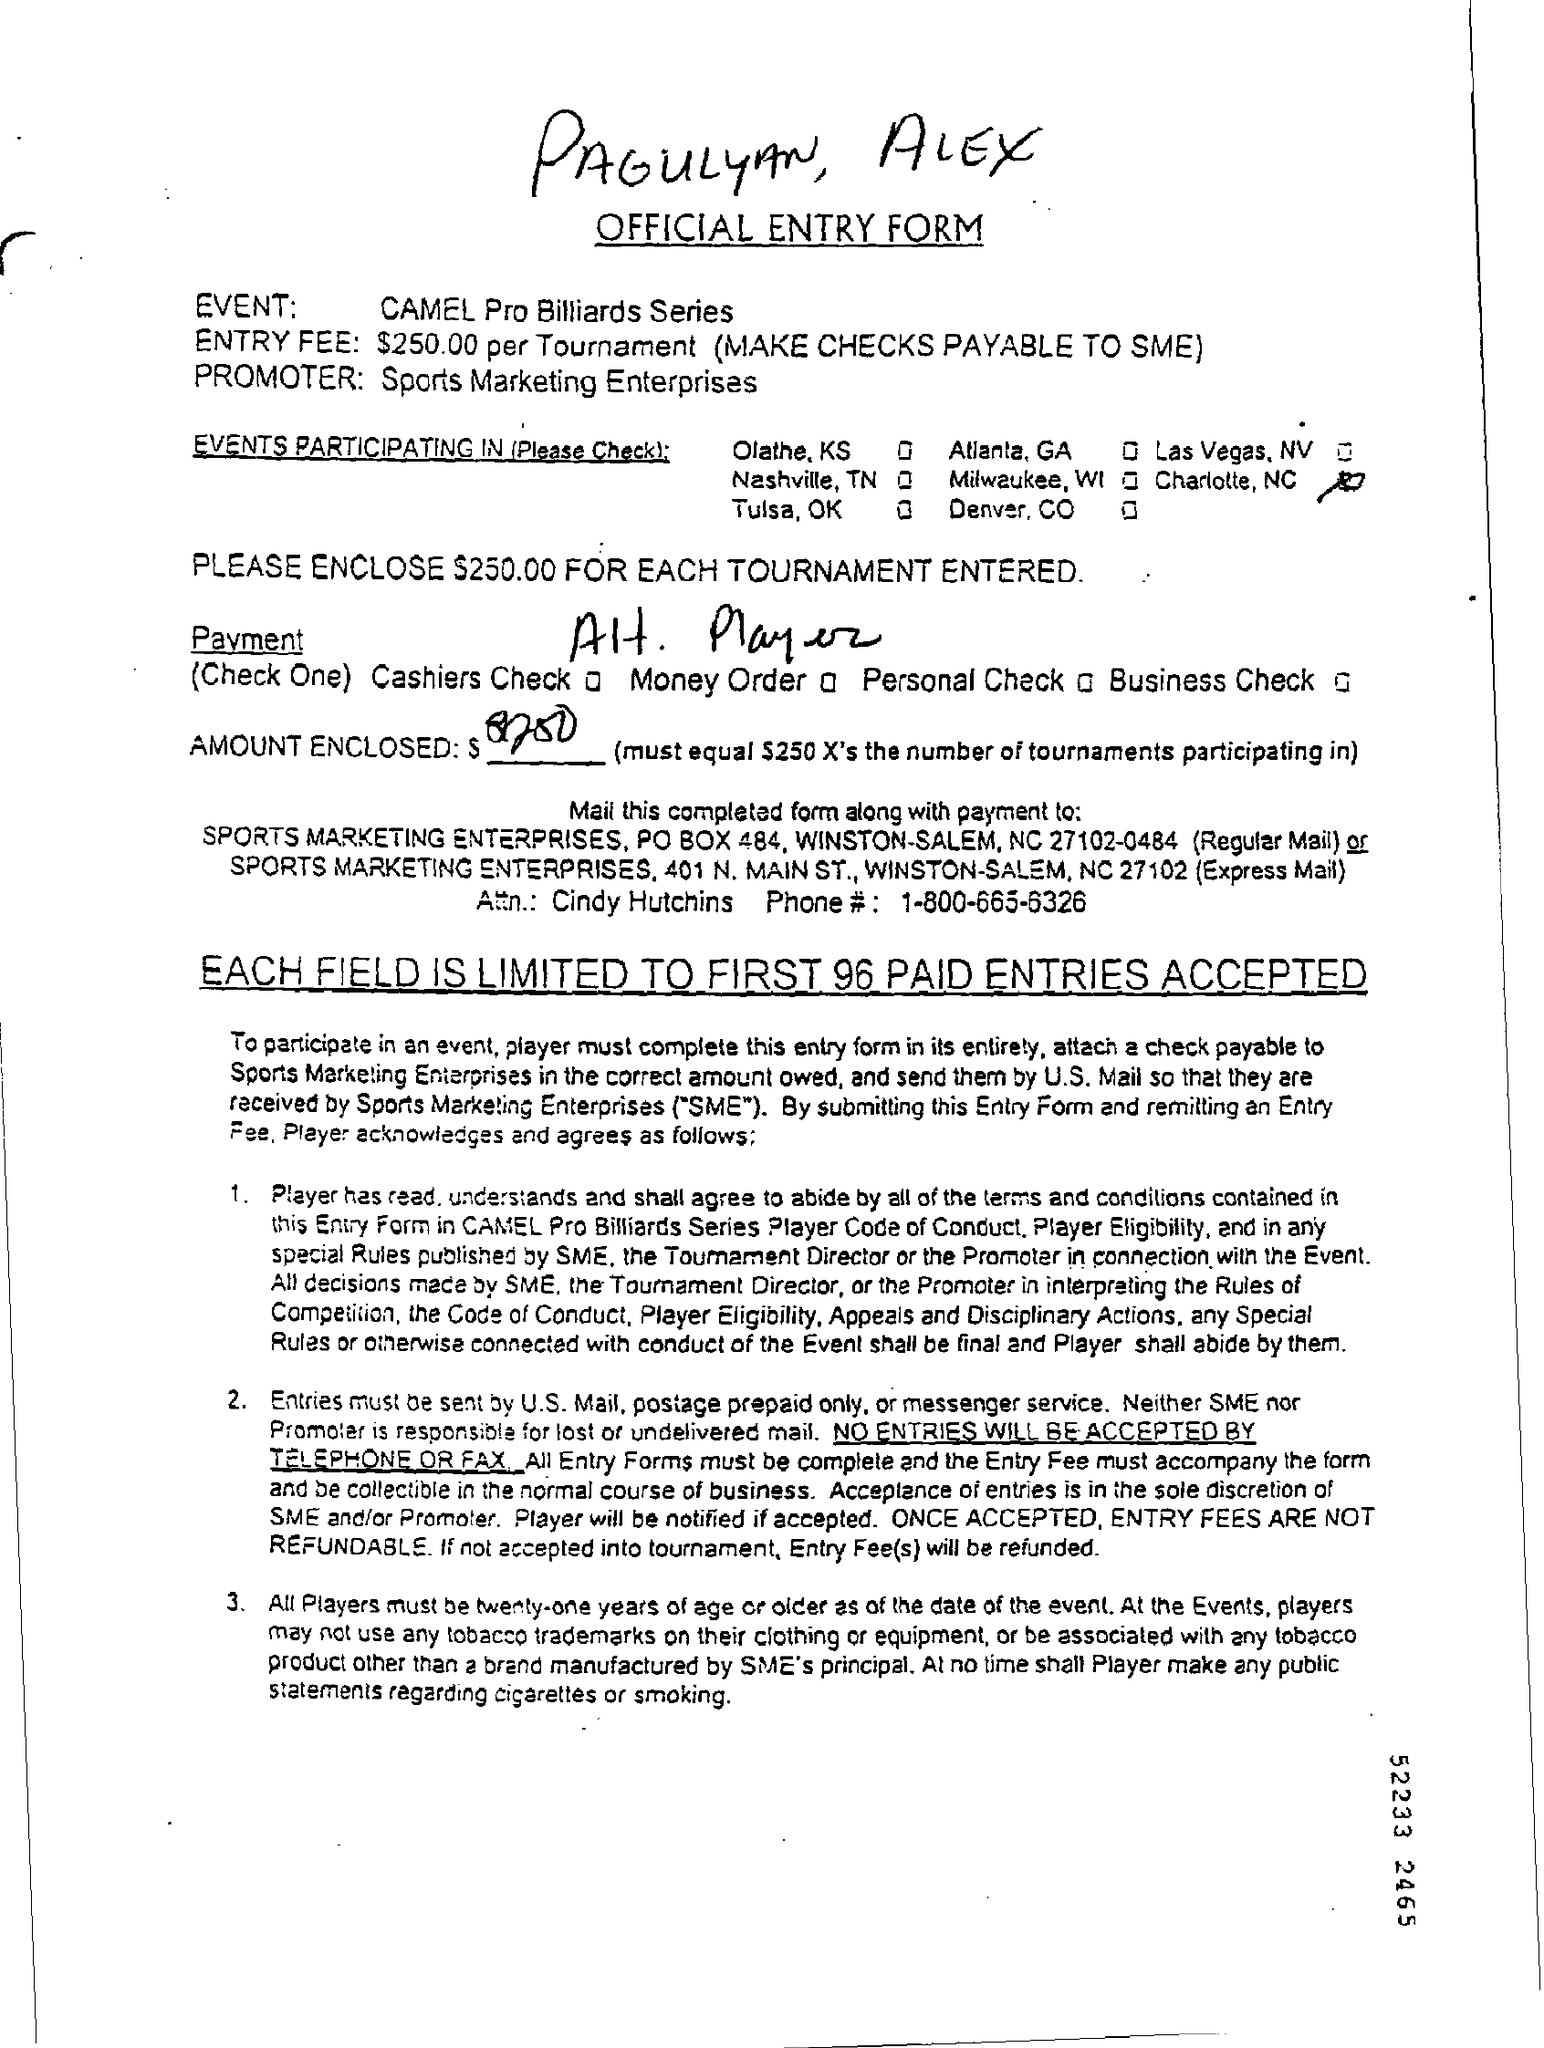Draw attention to some important aspects in this diagram. It is mandatory that all players be at least 21 years of age. The entry fee for each tournament is $250.00. The handwritten names of PAGULYAN and ALEX are at the top. Sports Marketing Enterprises is the promoter of the event. The CAMEL Pro Billiards Series is an event. 